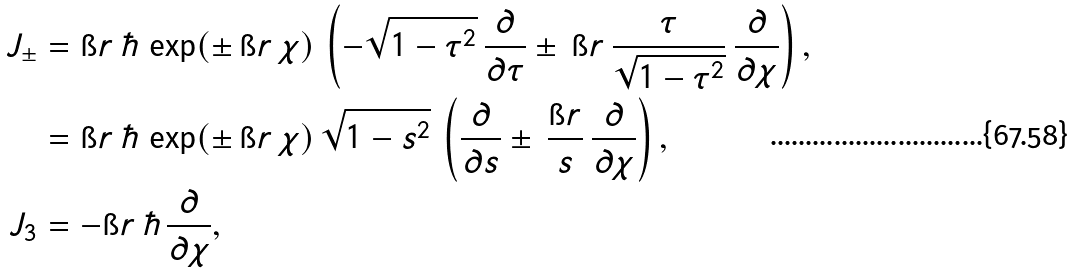<formula> <loc_0><loc_0><loc_500><loc_500>J _ { \pm } & = \i r \, \hbar { \, } \exp ( \pm \, \i r \, \chi ) \, \left ( - \sqrt { 1 - \tau ^ { 2 } } \, \frac { \partial } { \partial \tau } \pm \, \i r \, \frac { \tau } { \sqrt { 1 - \tau ^ { 2 } } } \, \frac { \partial } { \partial \chi } \right ) , \\ & = \i r \, \hbar { \, } \exp ( \pm \, \i r \, \chi ) \, \sqrt { 1 - s ^ { 2 } } \, \left ( \frac { \partial } { \partial s } \pm \, \frac { \i r } { s } \, \frac { \partial } { \partial \chi } \right ) , \\ J _ { 3 } & = - \i r \, \hbar { \, } \frac { \partial } { \partial \chi } ,</formula> 